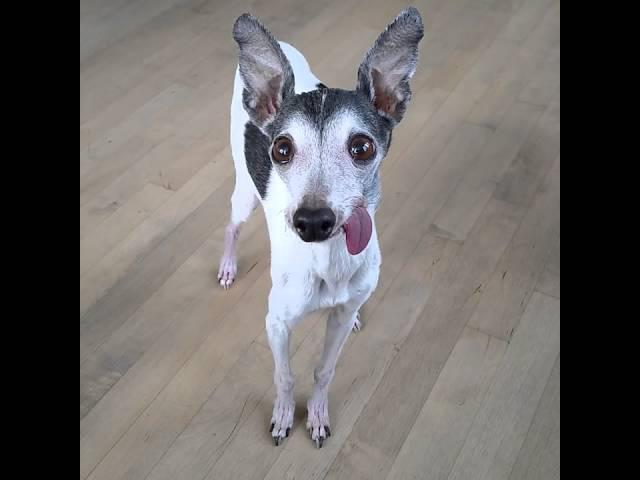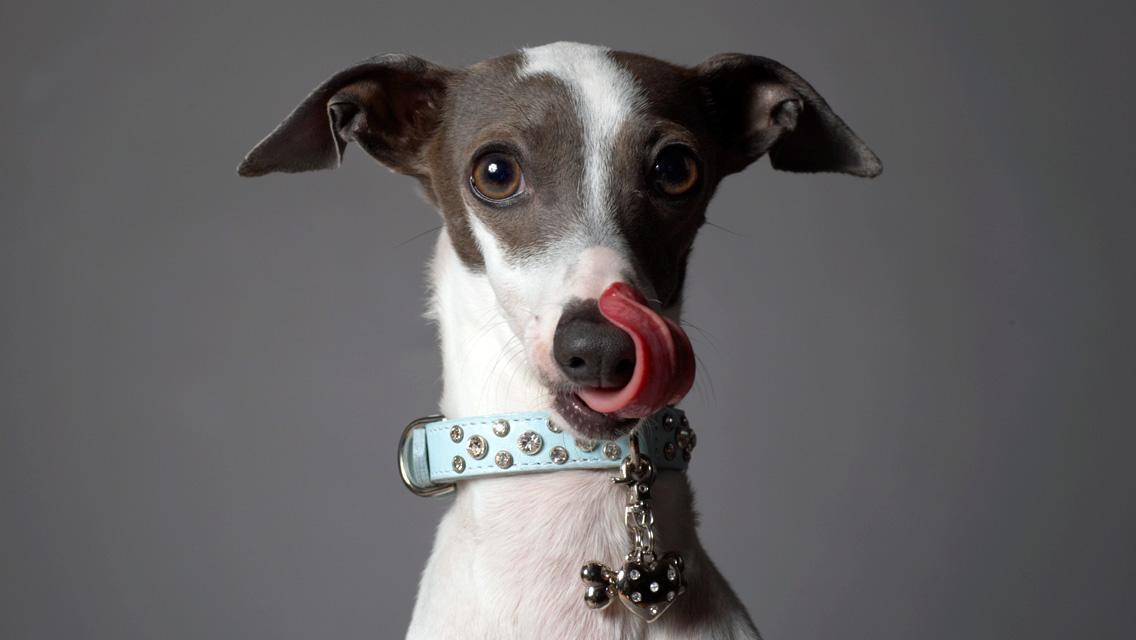The first image is the image on the left, the second image is the image on the right. Assess this claim about the two images: "An image shows at least three dogs inside some type of container.". Correct or not? Answer yes or no. No. The first image is the image on the left, the second image is the image on the right. For the images displayed, is the sentence "At least three four dogs are sitting down." factually correct? Answer yes or no. No. 